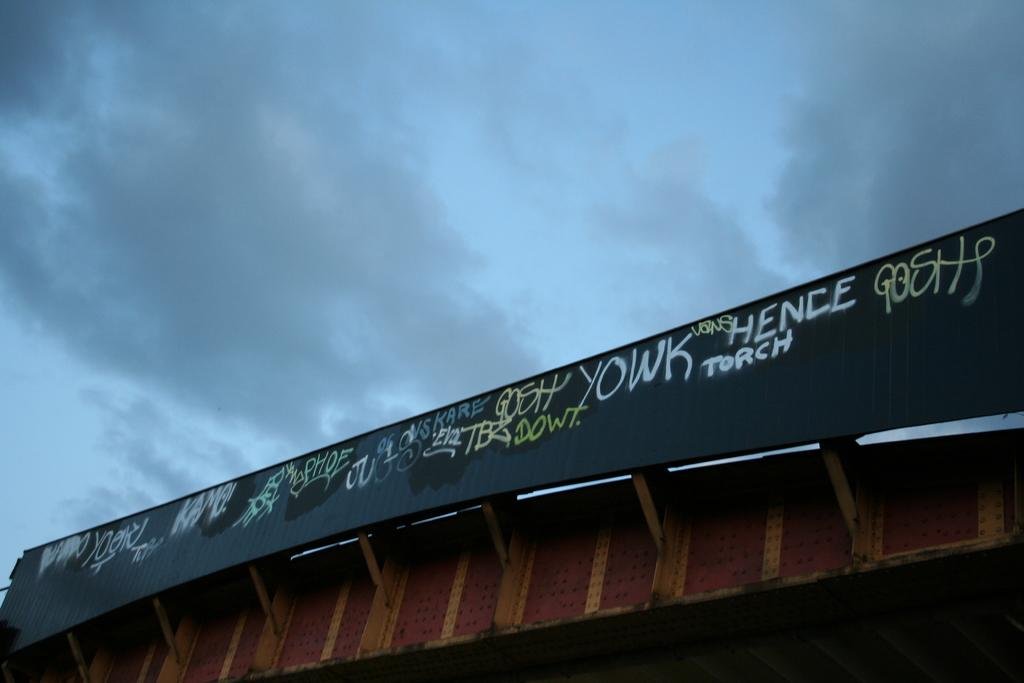<image>
Render a clear and concise summary of the photo. a bridge with graffiti on it saying Hence Torch 